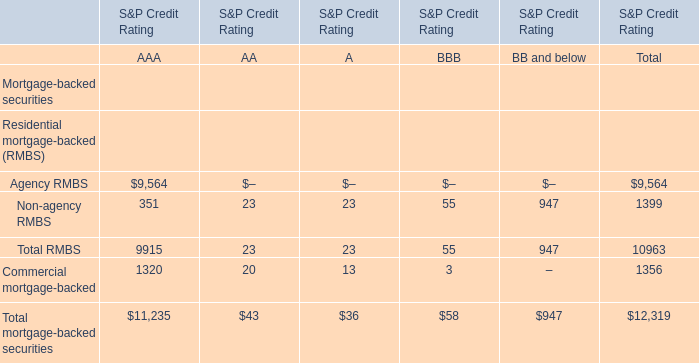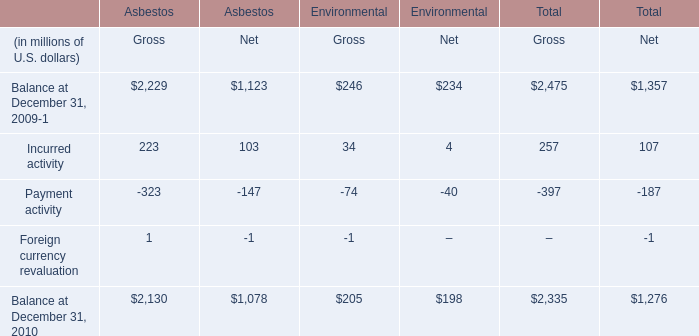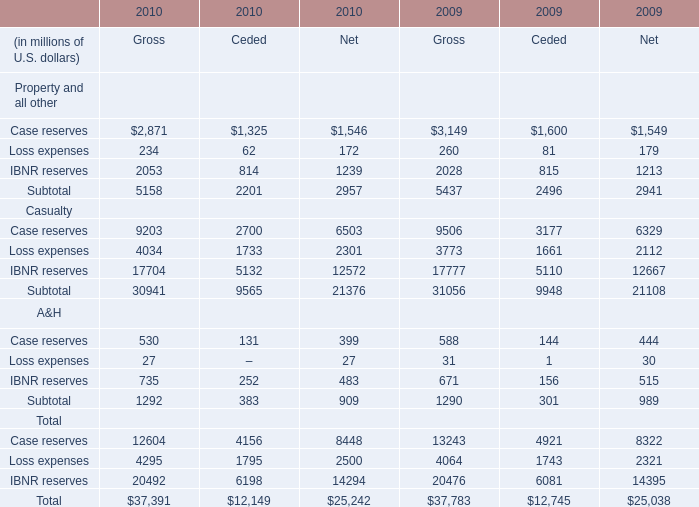What's the greatest value of net of reserves for property in 2010? 
Answer: case reserves. 